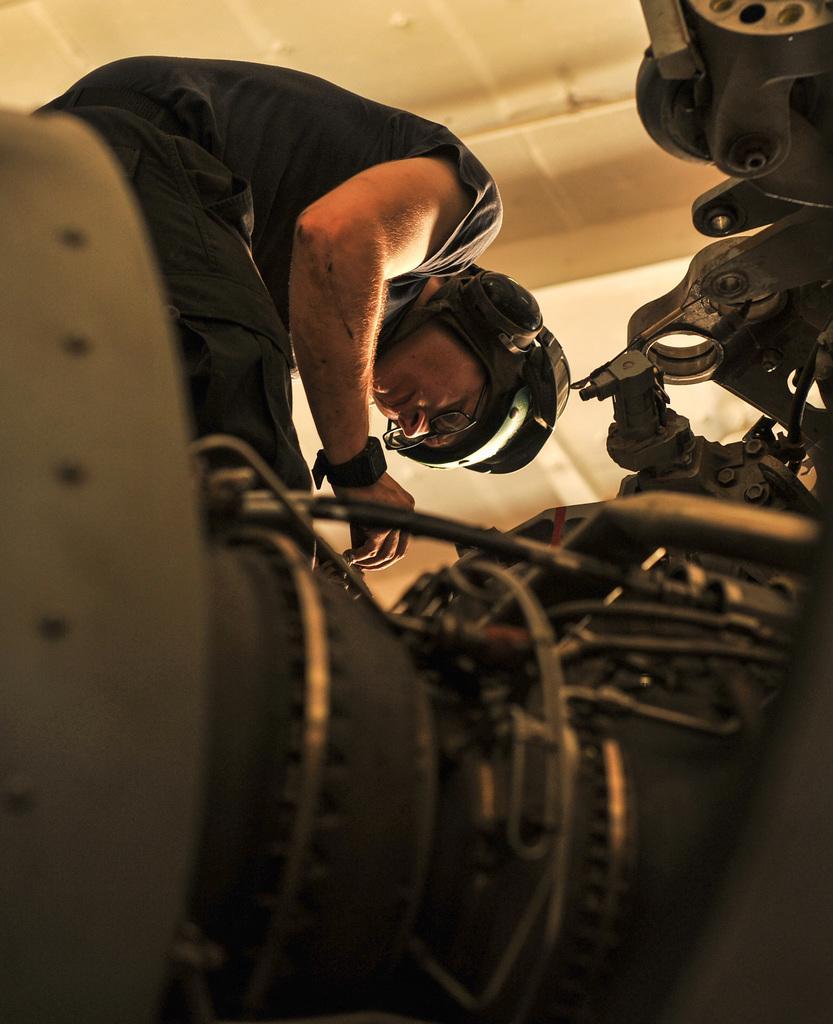Describe this image in one or two sentences. In the image i can see a person wearing black dress,h and watch,helmet,spectacles and i also see a motorbike. 